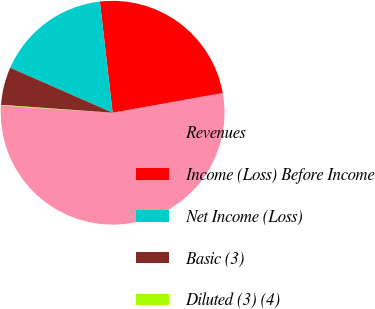<chart> <loc_0><loc_0><loc_500><loc_500><pie_chart><fcel>Revenues<fcel>Income (Loss) Before Income<fcel>Net Income (Loss)<fcel>Basic (3)<fcel>Diluted (3) (4)<nl><fcel>53.85%<fcel>23.99%<fcel>16.6%<fcel>5.47%<fcel>0.09%<nl></chart> 